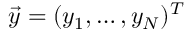<formula> <loc_0><loc_0><loc_500><loc_500>\vec { y } = ( y _ { 1 } , \dots , y _ { N } ) ^ { T }</formula> 